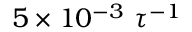Convert formula to latex. <formula><loc_0><loc_0><loc_500><loc_500>5 \times 1 0 ^ { - 3 } \tau ^ { - 1 }</formula> 